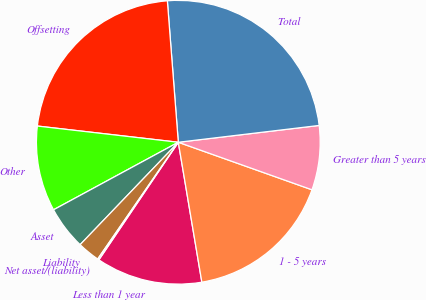Convert chart to OTSL. <chart><loc_0><loc_0><loc_500><loc_500><pie_chart><fcel>Less than 1 year<fcel>1 - 5 years<fcel>Greater than 5 years<fcel>Total<fcel>Offsetting<fcel>Other<fcel>Asset<fcel>Liability<fcel>Net asset/(liability)<nl><fcel>12.11%<fcel>16.91%<fcel>7.33%<fcel>24.34%<fcel>21.95%<fcel>9.72%<fcel>4.94%<fcel>2.55%<fcel>0.16%<nl></chart> 